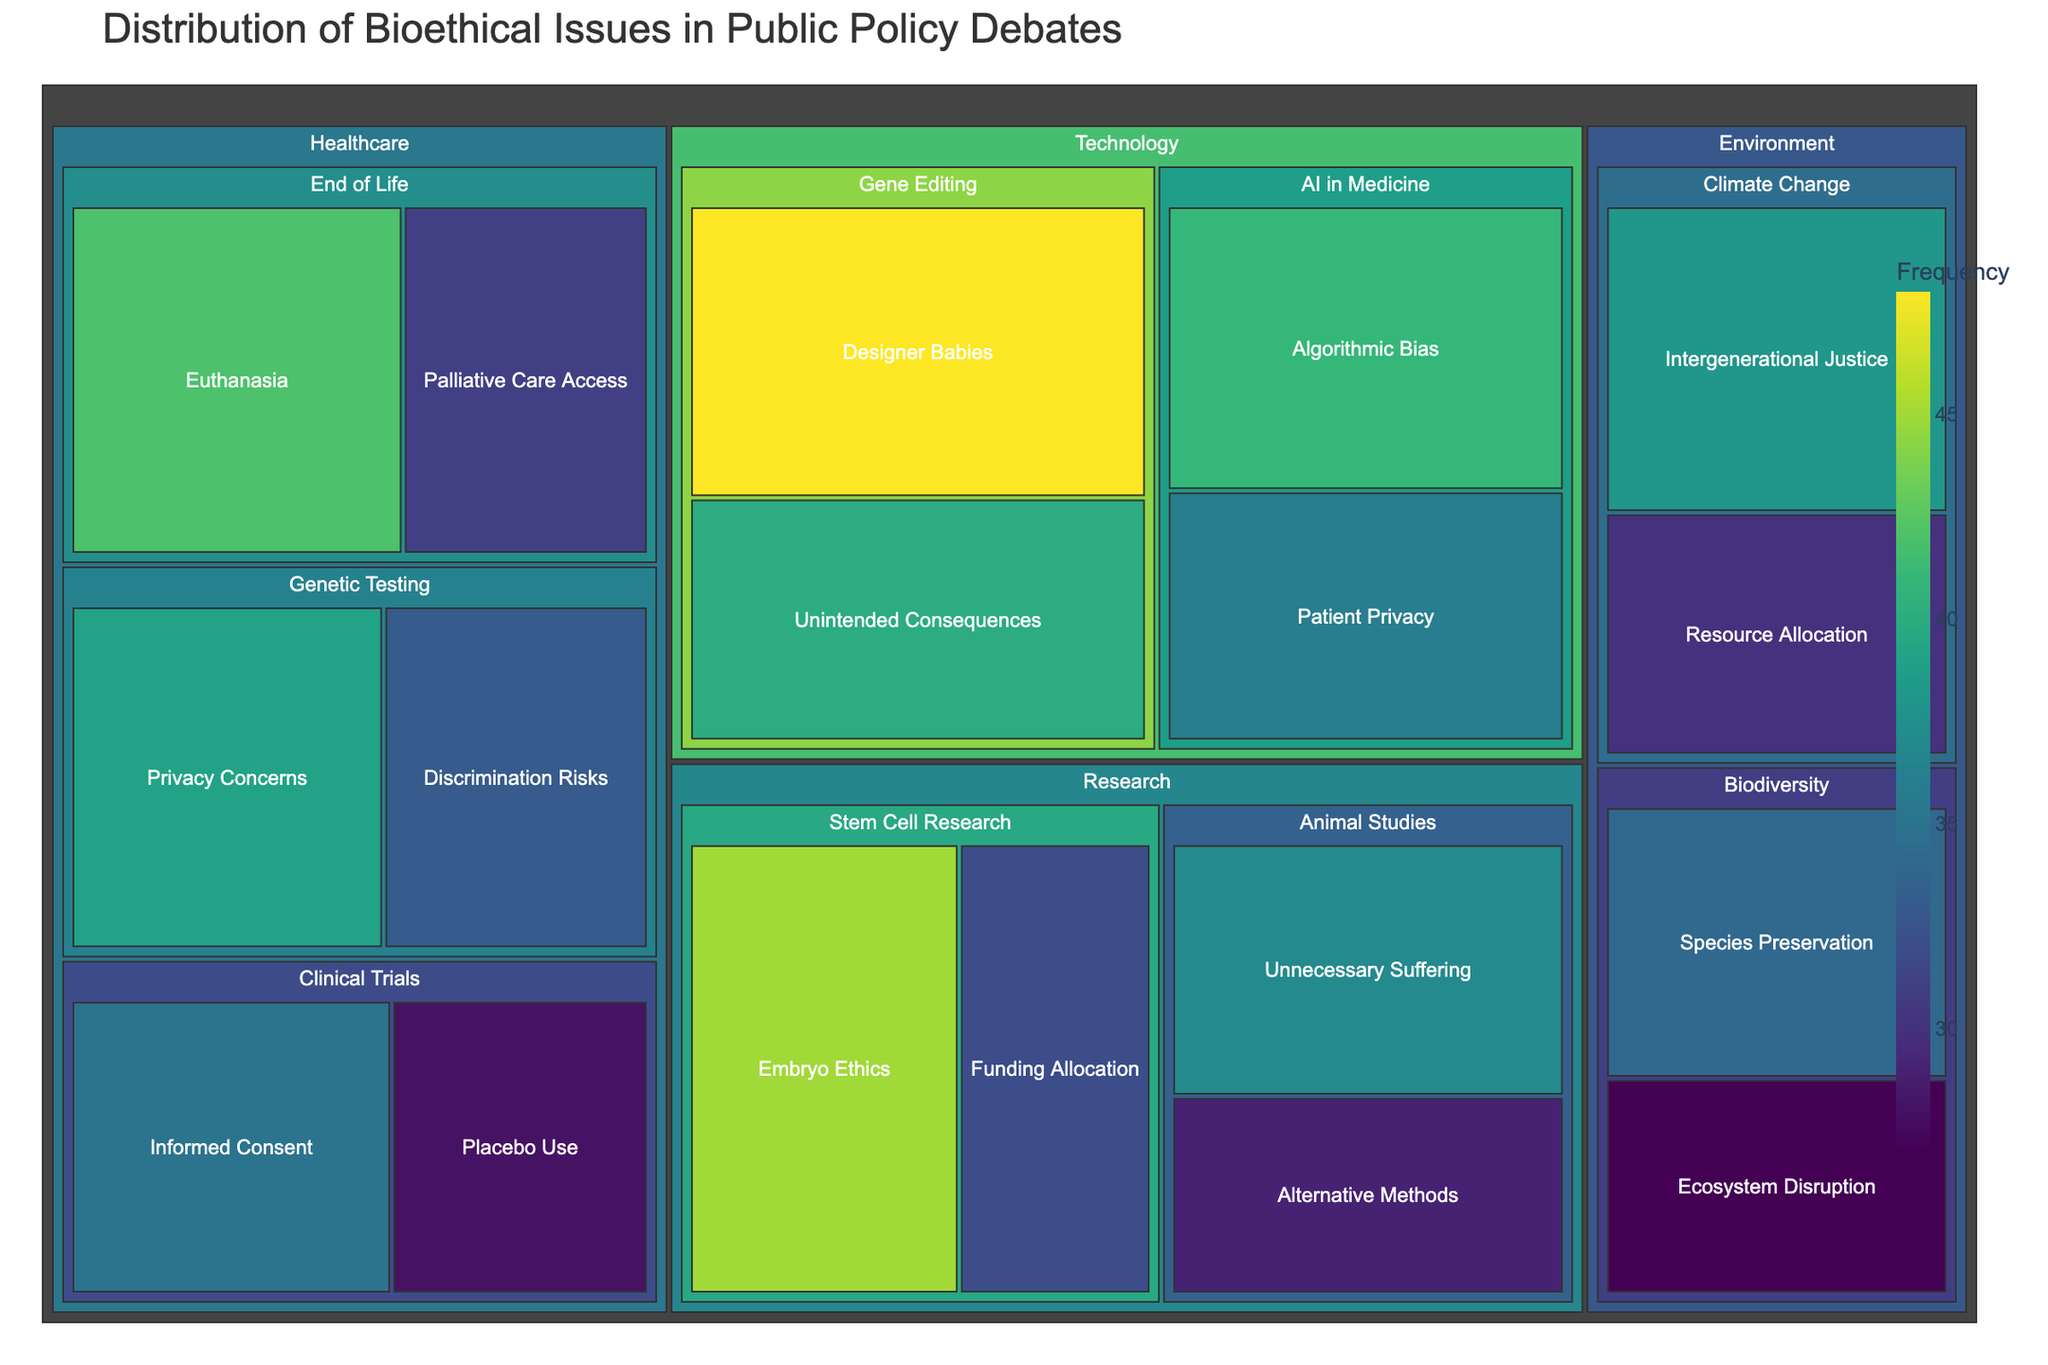What's the title of the treemap? The title is located at the top of the figure and is usually presented in larger font size. Here, it reads "Distribution of Bioethical Issues in Public Policy Debates."
Answer: Distribution of Bioethical Issues in Public Policy Debates Which domain has the highest frequency issue? The domain with the issue that has the largest area and highest frequency on the treemap is "Technology" with the issue "Designer Babies" at 48.
Answer: Technology How many categories fall under the domain 'Healthcare'? Each unique path segment under "Healthcare" with sub-segments represents different categories. In this case, "Clinical Trials," "End of Life," and "Genetic Testing" are the categories. There are 3 categories under Healthcare.
Answer: 3 What is the combined frequency of issues under 'AI in Medicine'? Add the frequencies of issues under "AI in Medicine": "Algorithmic Bias" (41) and "Patient Privacy" (36). The combined frequency is 41+36.
Answer: 77 Which category has the issue with the lowest frequency in the 'Environment' domain? Check the issues under each category in the "Environment" domain to find the lowest frequency. "Biodiversity" with "Ecosystem Disruption" at 27 has the lowest frequency.
Answer: Biodiversity Is 'Patient Privacy' a more frequent issue in 'AI in Medicine' or 'Genetic Testing'? Compare the frequencies of "Patient Privacy" in both categories. "AI in Medicine" has "Patient Privacy" at 36, while "Genetic Testing" does not have "Patient Privacy." Thus, "AI in Medicine" has a more frequent issue of "Patient Privacy."
Answer: AI in Medicine Which category encompasses the highest number of different issues? Determine the number of issues listed under each category by examining the sub-segments. The category "Genetic Testing" in the "Healthcare" domain has two issues: "Privacy Concerns" and "Discrimination Risks." There are categories with an equal number of issues, but "Genetic Testing" is consistent.
Answer: Genetic Testing What is the frequency difference between 'Embryo Ethics' and 'Funding Allocation' in 'Stem Cell Research'? Subtract the frequency of "Funding Allocation" (32) from "Embryo Ethics" (45). The frequency difference is 45 - 32.
Answer: 13 Which issue in the 'Climate Change' category has a higher frequency? Compare the frequencies of issues in "Climate Change": "Intergenerational Justice" (38) and "Resource Allocation" (30). "Intergenerational Justice" has a higher frequency.
Answer: Intergenerational Justice What's the total frequency of the issues categorized under 'Animal Studies'? Add the frequencies of the issues under "Animal Studies": "Unnecessary Suffering" (37) and "Alternative Methods" (29). The total frequency is 37 + 29.
Answer: 66 